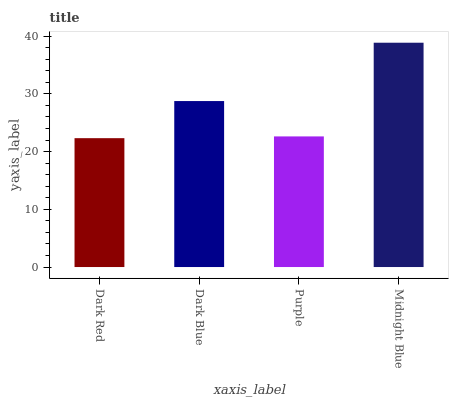Is Dark Red the minimum?
Answer yes or no. Yes. Is Midnight Blue the maximum?
Answer yes or no. Yes. Is Dark Blue the minimum?
Answer yes or no. No. Is Dark Blue the maximum?
Answer yes or no. No. Is Dark Blue greater than Dark Red?
Answer yes or no. Yes. Is Dark Red less than Dark Blue?
Answer yes or no. Yes. Is Dark Red greater than Dark Blue?
Answer yes or no. No. Is Dark Blue less than Dark Red?
Answer yes or no. No. Is Dark Blue the high median?
Answer yes or no. Yes. Is Purple the low median?
Answer yes or no. Yes. Is Midnight Blue the high median?
Answer yes or no. No. Is Midnight Blue the low median?
Answer yes or no. No. 